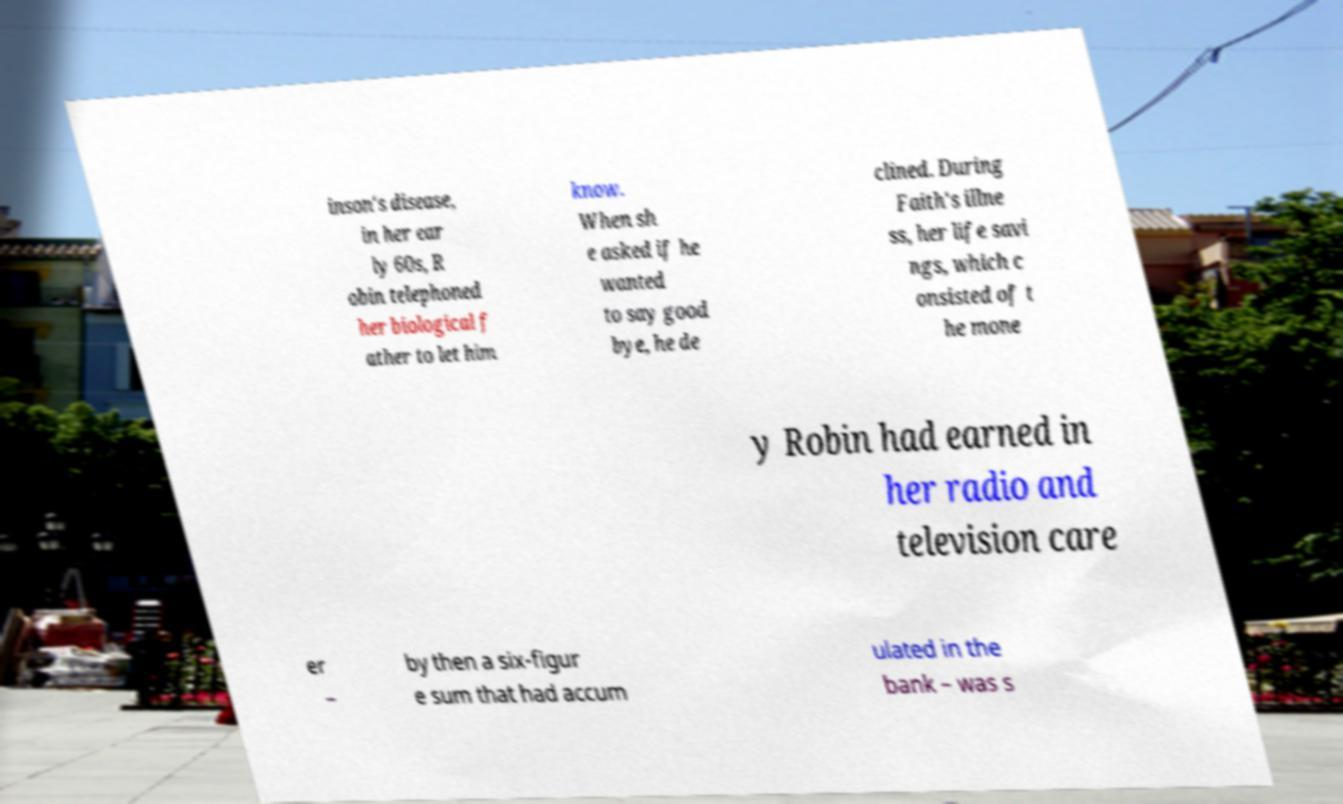Can you read and provide the text displayed in the image?This photo seems to have some interesting text. Can you extract and type it out for me? inson's disease, in her ear ly 60s, R obin telephoned her biological f ather to let him know. When sh e asked if he wanted to say good bye, he de clined. During Faith's illne ss, her life savi ngs, which c onsisted of t he mone y Robin had earned in her radio and television care er – by then a six-figur e sum that had accum ulated in the bank – was s 